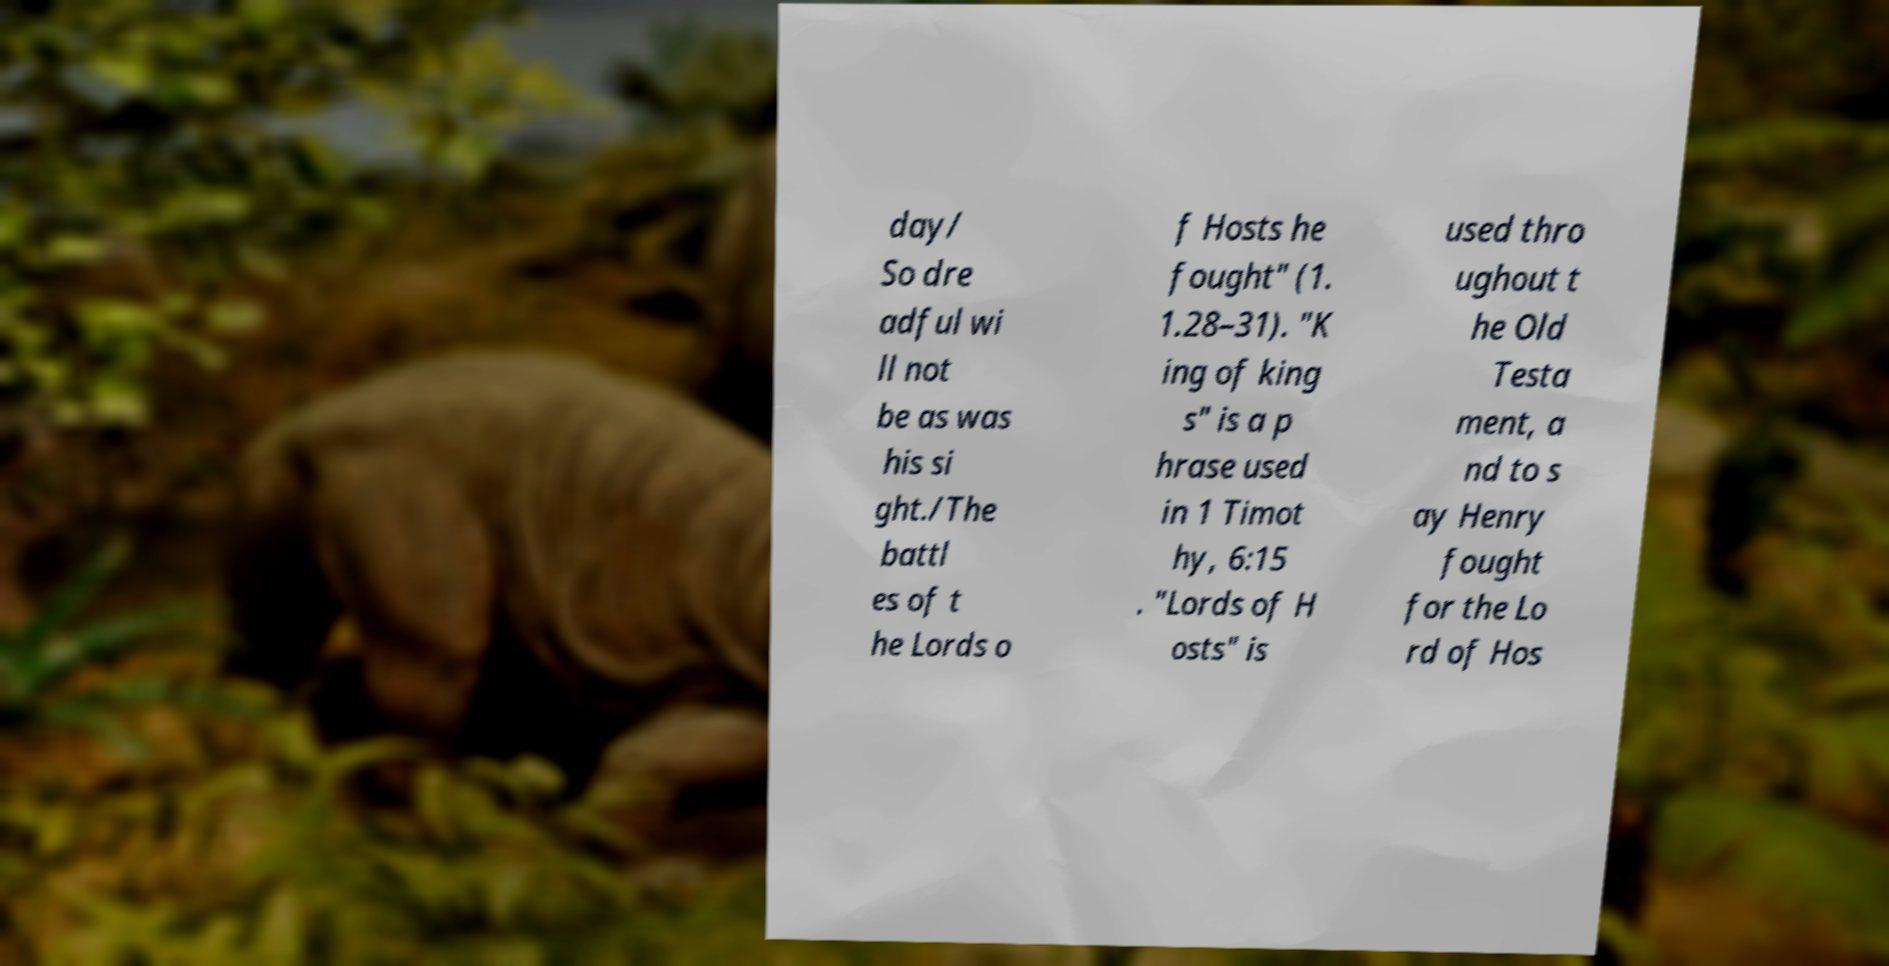Could you extract and type out the text from this image? day/ So dre adful wi ll not be as was his si ght./The battl es of t he Lords o f Hosts he fought" (1. 1.28–31). "K ing of king s" is a p hrase used in 1 Timot hy, 6:15 . "Lords of H osts" is used thro ughout t he Old Testa ment, a nd to s ay Henry fought for the Lo rd of Hos 